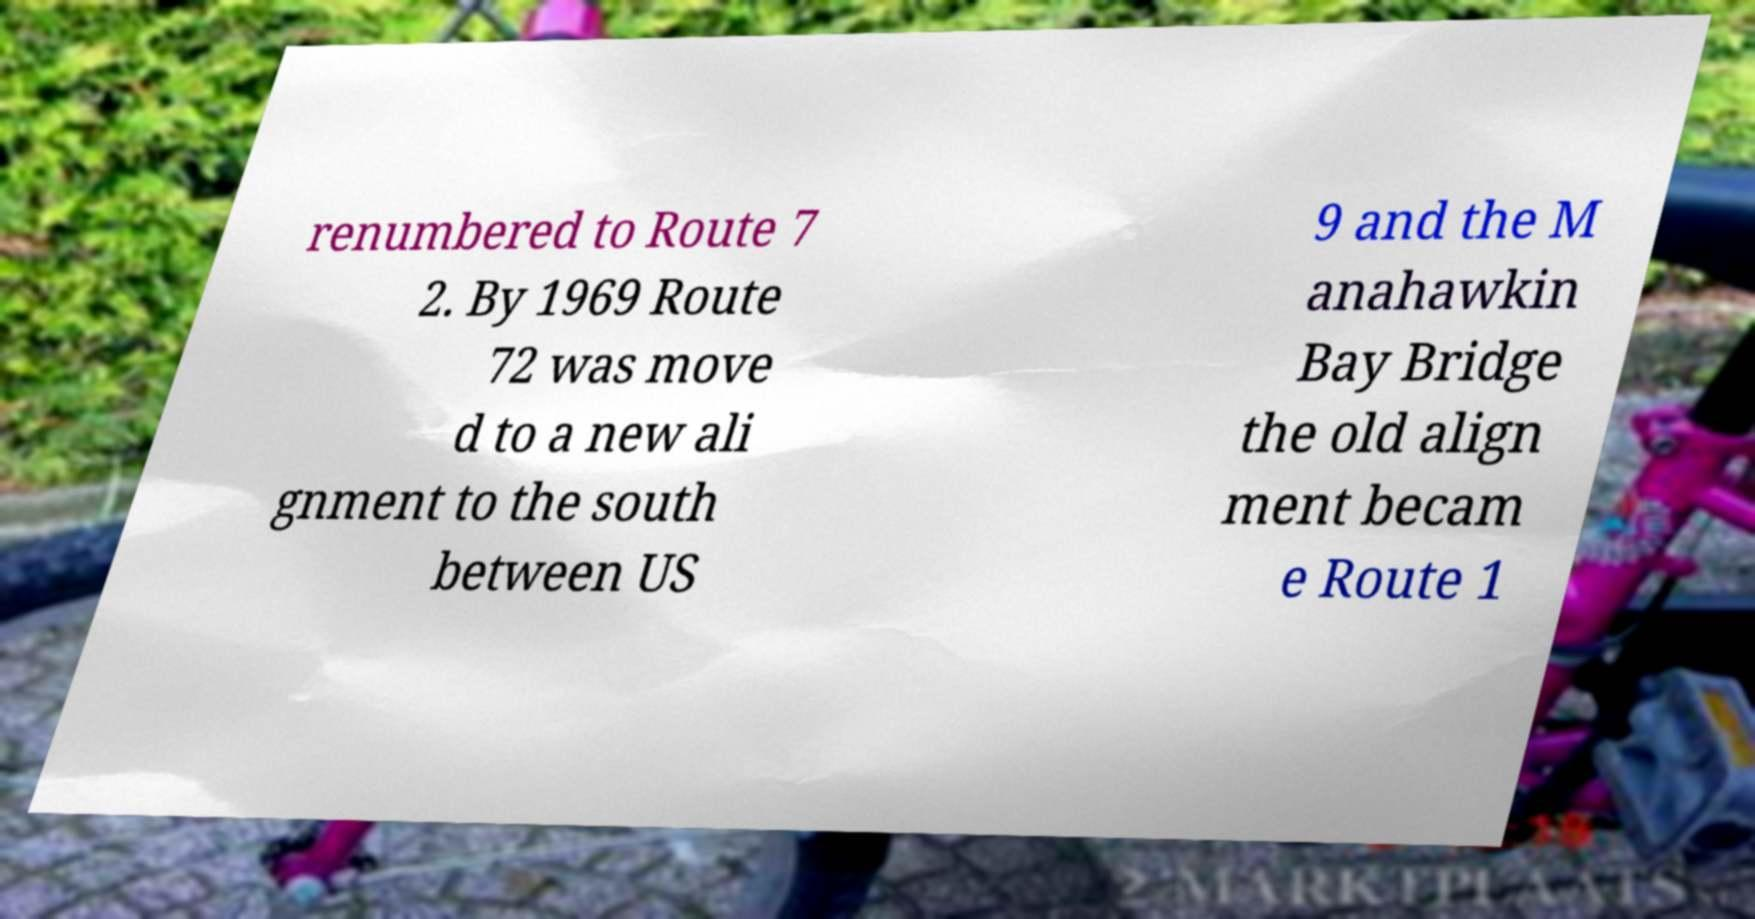I need the written content from this picture converted into text. Can you do that? renumbered to Route 7 2. By 1969 Route 72 was move d to a new ali gnment to the south between US 9 and the M anahawkin Bay Bridge the old align ment becam e Route 1 